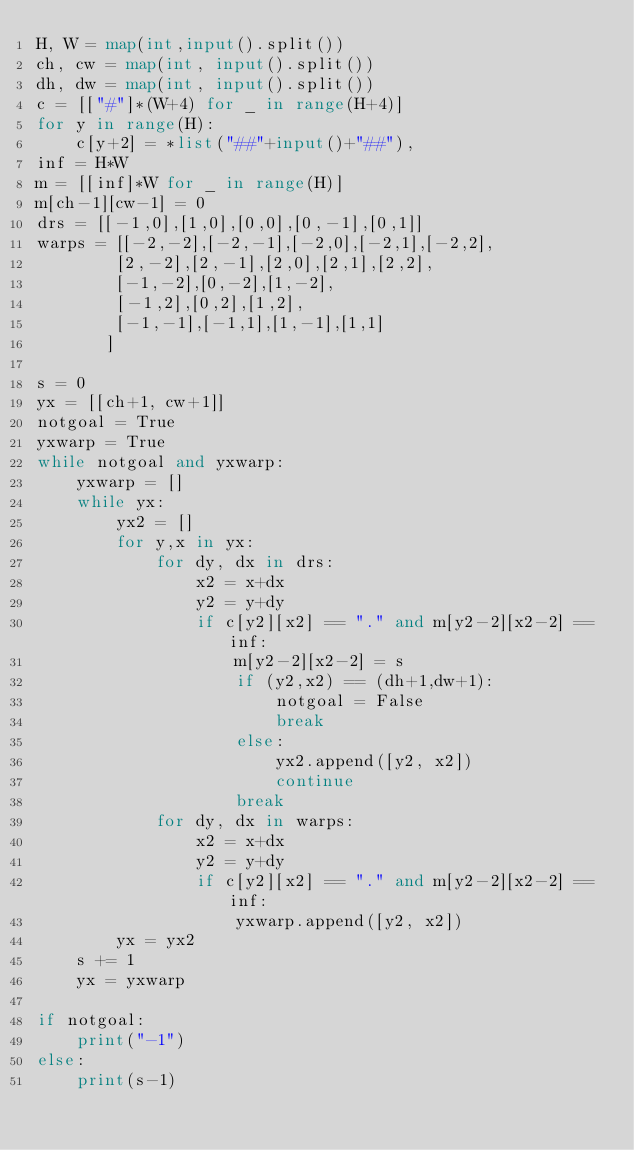Convert code to text. <code><loc_0><loc_0><loc_500><loc_500><_Python_>H, W = map(int,input().split())
ch, cw = map(int, input().split())
dh, dw = map(int, input().split())
c = [["#"]*(W+4) for _ in range(H+4)]
for y in range(H):
    c[y+2] = *list("##"+input()+"##"), 
inf = H*W
m = [[inf]*W for _ in range(H)]
m[ch-1][cw-1] = 0
drs = [[-1,0],[1,0],[0,0],[0,-1],[0,1]]
warps = [[-2,-2],[-2,-1],[-2,0],[-2,1],[-2,2],
        [2,-2],[2,-1],[2,0],[2,1],[2,2],
        [-1,-2],[0,-2],[1,-2],
        [-1,2],[0,2],[1,2],
        [-1,-1],[-1,1],[1,-1],[1,1]
       ]

s = 0
yx = [[ch+1, cw+1]]
notgoal = True
yxwarp = True
while notgoal and yxwarp:
    yxwarp = []
    while yx:
        yx2 = []
        for y,x in yx:
            for dy, dx in drs:
                x2 = x+dx
                y2 = y+dy
                if c[y2][x2] == "." and m[y2-2][x2-2] == inf:
                    m[y2-2][x2-2] = s
                    if (y2,x2) == (dh+1,dw+1):
                        notgoal = False
                        break
                    else:
                        yx2.append([y2, x2])
                        continue
                    break
            for dy, dx in warps:
                x2 = x+dx
                y2 = y+dy
                if c[y2][x2] == "." and m[y2-2][x2-2] == inf:
                    yxwarp.append([y2, x2])
        yx = yx2
    s += 1
    yx = yxwarp
    
if notgoal:
    print("-1")
else:
    print(s-1)</code> 